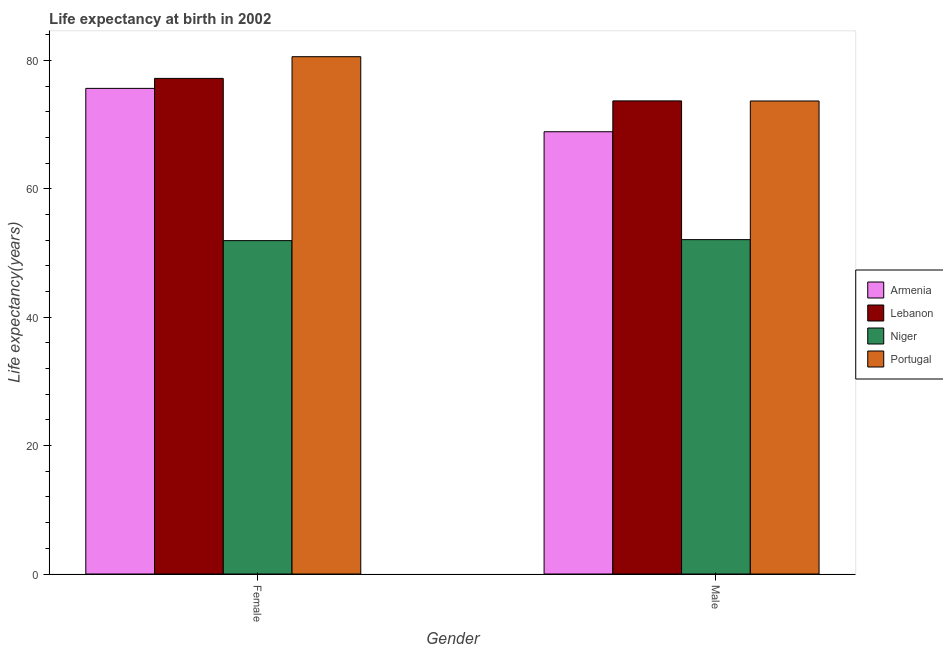How many groups of bars are there?
Offer a terse response. 2. Are the number of bars on each tick of the X-axis equal?
Give a very brief answer. Yes. How many bars are there on the 2nd tick from the right?
Provide a short and direct response. 4. What is the label of the 1st group of bars from the left?
Your answer should be compact. Female. What is the life expectancy(male) in Lebanon?
Your answer should be very brief. 73.71. Across all countries, what is the maximum life expectancy(female)?
Your answer should be very brief. 80.6. Across all countries, what is the minimum life expectancy(female)?
Give a very brief answer. 51.94. In which country was the life expectancy(female) minimum?
Your response must be concise. Niger. What is the total life expectancy(male) in the graph?
Your answer should be very brief. 268.41. What is the difference between the life expectancy(female) in Niger and that in Armenia?
Give a very brief answer. -23.72. What is the difference between the life expectancy(male) in Niger and the life expectancy(female) in Armenia?
Your response must be concise. -23.56. What is the average life expectancy(female) per country?
Make the answer very short. 71.36. What is the difference between the life expectancy(male) and life expectancy(female) in Portugal?
Give a very brief answer. -6.9. What is the ratio of the life expectancy(female) in Armenia to that in Portugal?
Provide a short and direct response. 0.94. In how many countries, is the life expectancy(male) greater than the average life expectancy(male) taken over all countries?
Offer a very short reply. 3. What does the 1st bar from the left in Male represents?
Give a very brief answer. Armenia. What does the 4th bar from the right in Male represents?
Provide a short and direct response. Armenia. How many bars are there?
Make the answer very short. 8. Are all the bars in the graph horizontal?
Provide a succinct answer. No. Does the graph contain grids?
Your answer should be compact. No. Where does the legend appear in the graph?
Offer a terse response. Center right. How many legend labels are there?
Give a very brief answer. 4. What is the title of the graph?
Keep it short and to the point. Life expectancy at birth in 2002. Does "Central Europe" appear as one of the legend labels in the graph?
Your answer should be very brief. No. What is the label or title of the X-axis?
Give a very brief answer. Gender. What is the label or title of the Y-axis?
Your answer should be compact. Life expectancy(years). What is the Life expectancy(years) of Armenia in Female?
Your response must be concise. 75.66. What is the Life expectancy(years) of Lebanon in Female?
Keep it short and to the point. 77.22. What is the Life expectancy(years) in Niger in Female?
Provide a short and direct response. 51.94. What is the Life expectancy(years) of Portugal in Female?
Give a very brief answer. 80.6. What is the Life expectancy(years) in Armenia in Male?
Provide a succinct answer. 68.91. What is the Life expectancy(years) of Lebanon in Male?
Your response must be concise. 73.71. What is the Life expectancy(years) of Niger in Male?
Your answer should be very brief. 52.1. What is the Life expectancy(years) in Portugal in Male?
Offer a very short reply. 73.7. Across all Gender, what is the maximum Life expectancy(years) in Armenia?
Offer a very short reply. 75.66. Across all Gender, what is the maximum Life expectancy(years) of Lebanon?
Keep it short and to the point. 77.22. Across all Gender, what is the maximum Life expectancy(years) of Niger?
Make the answer very short. 52.1. Across all Gender, what is the maximum Life expectancy(years) of Portugal?
Offer a very short reply. 80.6. Across all Gender, what is the minimum Life expectancy(years) in Armenia?
Ensure brevity in your answer.  68.91. Across all Gender, what is the minimum Life expectancy(years) of Lebanon?
Your answer should be compact. 73.71. Across all Gender, what is the minimum Life expectancy(years) in Niger?
Your answer should be very brief. 51.94. Across all Gender, what is the minimum Life expectancy(years) in Portugal?
Provide a succinct answer. 73.7. What is the total Life expectancy(years) of Armenia in the graph?
Keep it short and to the point. 144.57. What is the total Life expectancy(years) of Lebanon in the graph?
Offer a terse response. 150.93. What is the total Life expectancy(years) of Niger in the graph?
Provide a short and direct response. 104.04. What is the total Life expectancy(years) in Portugal in the graph?
Keep it short and to the point. 154.3. What is the difference between the Life expectancy(years) in Armenia in Female and that in Male?
Provide a short and direct response. 6.76. What is the difference between the Life expectancy(years) in Lebanon in Female and that in Male?
Offer a very short reply. 3.51. What is the difference between the Life expectancy(years) of Niger in Female and that in Male?
Give a very brief answer. -0.15. What is the difference between the Life expectancy(years) of Armenia in Female and the Life expectancy(years) of Lebanon in Male?
Ensure brevity in your answer.  1.95. What is the difference between the Life expectancy(years) of Armenia in Female and the Life expectancy(years) of Niger in Male?
Ensure brevity in your answer.  23.57. What is the difference between the Life expectancy(years) in Armenia in Female and the Life expectancy(years) in Portugal in Male?
Keep it short and to the point. 1.96. What is the difference between the Life expectancy(years) of Lebanon in Female and the Life expectancy(years) of Niger in Male?
Offer a terse response. 25.12. What is the difference between the Life expectancy(years) of Lebanon in Female and the Life expectancy(years) of Portugal in Male?
Make the answer very short. 3.52. What is the difference between the Life expectancy(years) in Niger in Female and the Life expectancy(years) in Portugal in Male?
Your response must be concise. -21.76. What is the average Life expectancy(years) of Armenia per Gender?
Keep it short and to the point. 72.28. What is the average Life expectancy(years) in Lebanon per Gender?
Your answer should be compact. 75.46. What is the average Life expectancy(years) of Niger per Gender?
Offer a terse response. 52.02. What is the average Life expectancy(years) in Portugal per Gender?
Your answer should be very brief. 77.15. What is the difference between the Life expectancy(years) in Armenia and Life expectancy(years) in Lebanon in Female?
Provide a succinct answer. -1.55. What is the difference between the Life expectancy(years) of Armenia and Life expectancy(years) of Niger in Female?
Offer a very short reply. 23.72. What is the difference between the Life expectancy(years) of Armenia and Life expectancy(years) of Portugal in Female?
Make the answer very short. -4.94. What is the difference between the Life expectancy(years) of Lebanon and Life expectancy(years) of Niger in Female?
Provide a short and direct response. 25.27. What is the difference between the Life expectancy(years) in Lebanon and Life expectancy(years) in Portugal in Female?
Your response must be concise. -3.38. What is the difference between the Life expectancy(years) in Niger and Life expectancy(years) in Portugal in Female?
Ensure brevity in your answer.  -28.66. What is the difference between the Life expectancy(years) in Armenia and Life expectancy(years) in Lebanon in Male?
Keep it short and to the point. -4.8. What is the difference between the Life expectancy(years) in Armenia and Life expectancy(years) in Niger in Male?
Provide a succinct answer. 16.81. What is the difference between the Life expectancy(years) in Armenia and Life expectancy(years) in Portugal in Male?
Your answer should be very brief. -4.79. What is the difference between the Life expectancy(years) in Lebanon and Life expectancy(years) in Niger in Male?
Your answer should be very brief. 21.61. What is the difference between the Life expectancy(years) in Lebanon and Life expectancy(years) in Portugal in Male?
Your answer should be very brief. 0.01. What is the difference between the Life expectancy(years) of Niger and Life expectancy(years) of Portugal in Male?
Keep it short and to the point. -21.6. What is the ratio of the Life expectancy(years) in Armenia in Female to that in Male?
Keep it short and to the point. 1.1. What is the ratio of the Life expectancy(years) in Lebanon in Female to that in Male?
Give a very brief answer. 1.05. What is the ratio of the Life expectancy(years) of Portugal in Female to that in Male?
Your answer should be compact. 1.09. What is the difference between the highest and the second highest Life expectancy(years) in Armenia?
Ensure brevity in your answer.  6.76. What is the difference between the highest and the second highest Life expectancy(years) of Lebanon?
Give a very brief answer. 3.51. What is the difference between the highest and the second highest Life expectancy(years) in Niger?
Your answer should be very brief. 0.15. What is the difference between the highest and the second highest Life expectancy(years) in Portugal?
Offer a very short reply. 6.9. What is the difference between the highest and the lowest Life expectancy(years) of Armenia?
Your answer should be compact. 6.76. What is the difference between the highest and the lowest Life expectancy(years) of Lebanon?
Offer a terse response. 3.51. What is the difference between the highest and the lowest Life expectancy(years) in Niger?
Your answer should be compact. 0.15. What is the difference between the highest and the lowest Life expectancy(years) of Portugal?
Your response must be concise. 6.9. 